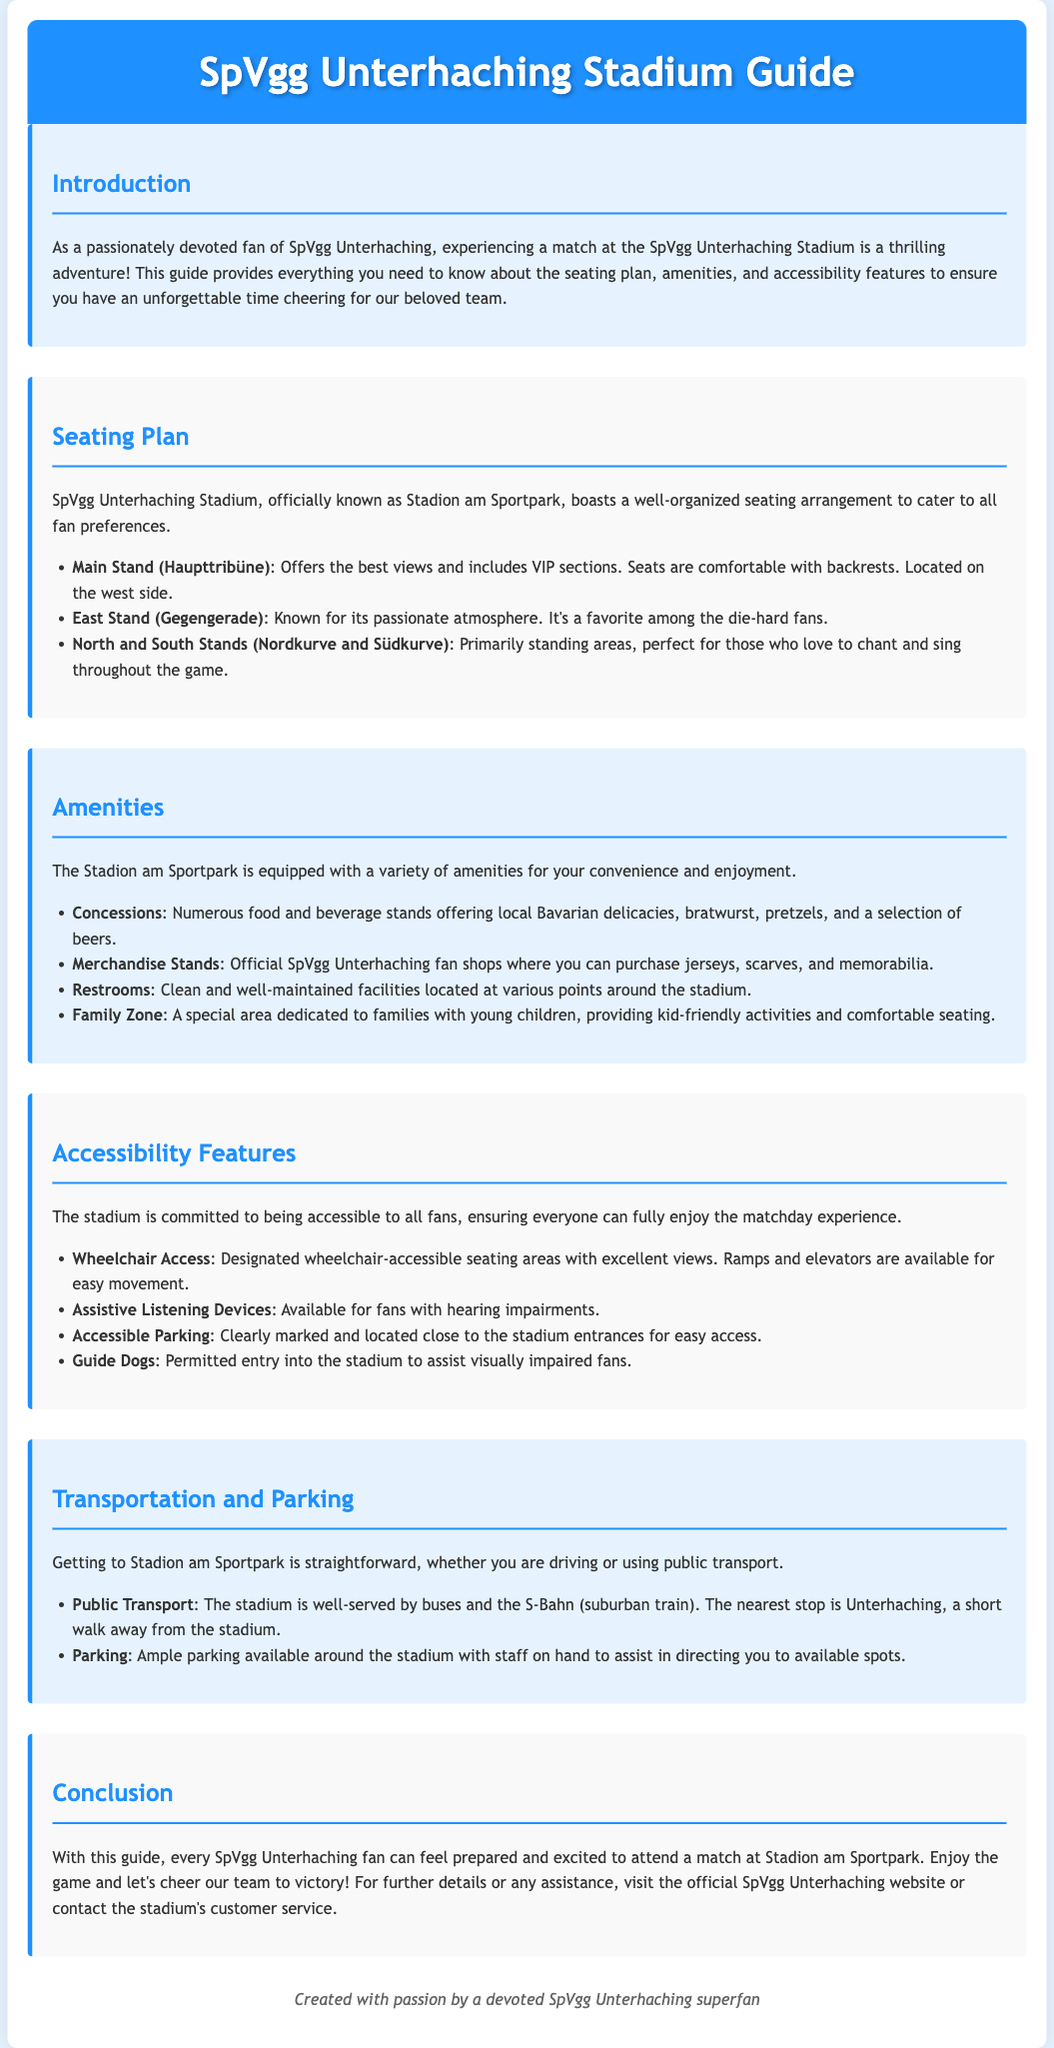What is the name of the stadium? The name of the stadium is provided in the introduction section of the document.
Answer: Stadion am Sportpark How many stands are mentioned in the seating plan? The seating plan lists three stands: Main Stand, East Stand, and North and South Stands.
Answer: Three What amenities are available at the stadium? The document lists specific amenities, including concessions, merchandise stands, restrooms, and a family zone.
Answer: Concessions, merchandise stands, restrooms, family zone What type of seating is offered in the North and South Stands? The document specifies that the North and South Stands are primarily standing areas for fans.
Answer: Standing areas What accessibility feature is available for visually impaired fans? The document mentions that guide dogs are permitted entry into the stadium for visually impaired fans.
Answer: Guide dogs What public transport option is nearest to the stadium? The document indicates that the nearest public transport stop is Unterhaching.
Answer: Unterhaching What is the primary purpose of the guide? The document's introduction states the purpose of the guide to enhance the matchday experience for fans.
Answer: Enhance matchday experience What is the color scheme of the stadium guide? The document describes a color scheme where various sections utilize light blue and white tones.
Answer: Light blue and white 